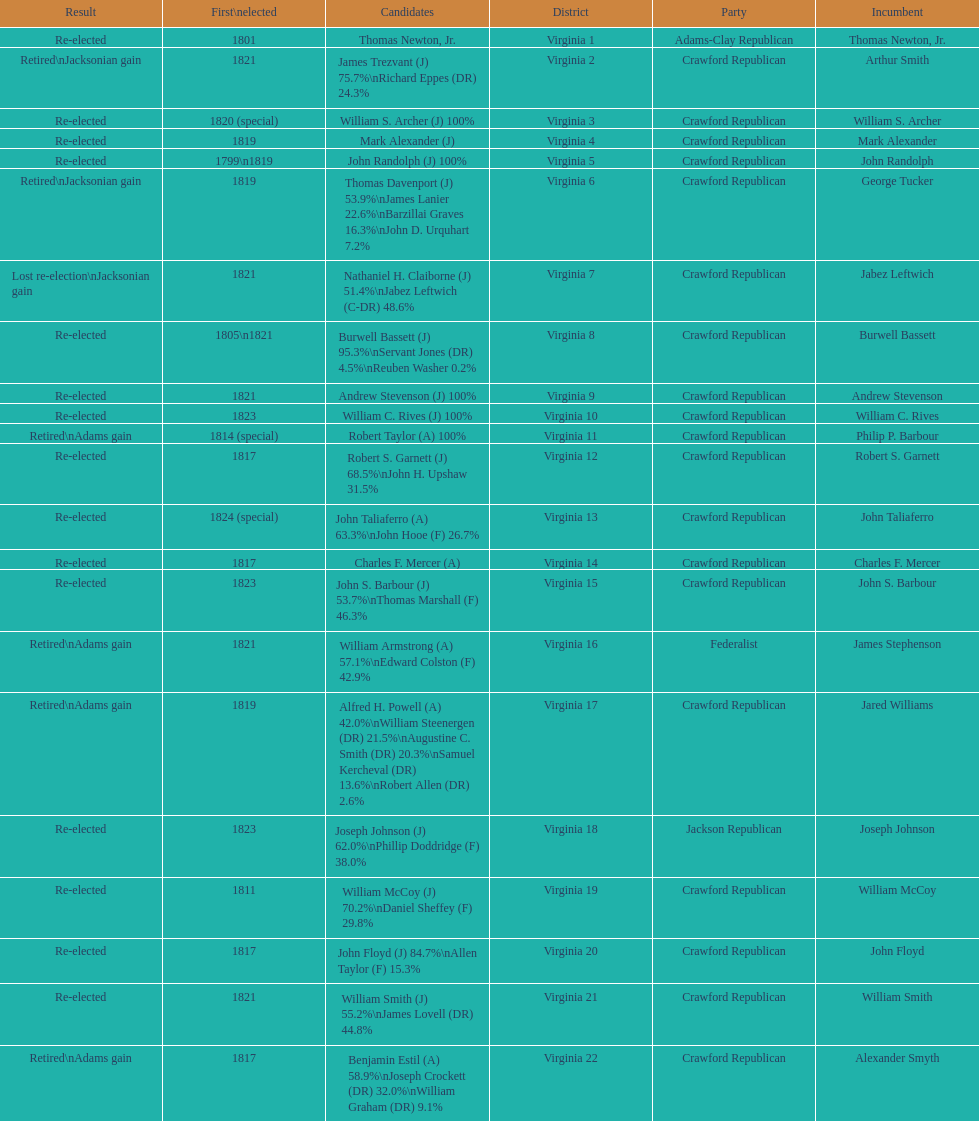Who was the one and only candidate elected for the first time in 1811? William McCoy. 